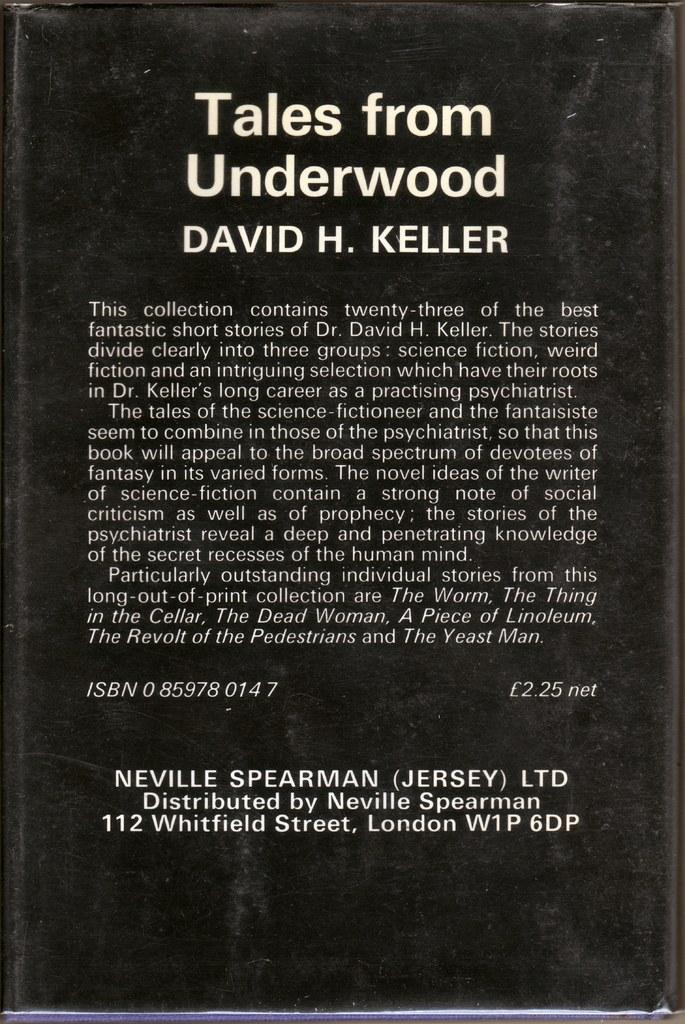<image>
Describe the image concisely. THE BACK OF A HARCOVERED BOOK BY DAVID KELLER CALLED TALES FROM UNDERWOOD 